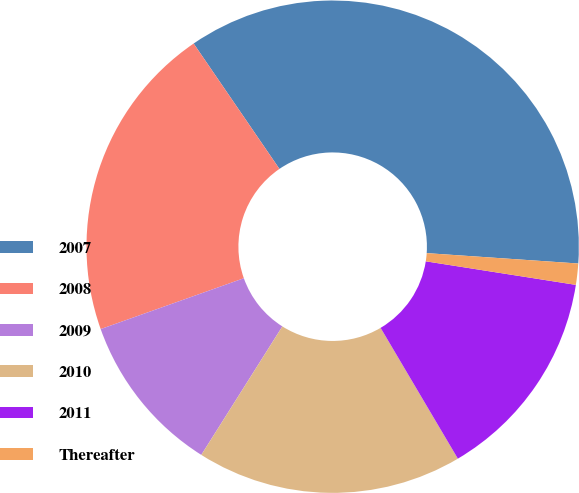Convert chart to OTSL. <chart><loc_0><loc_0><loc_500><loc_500><pie_chart><fcel>2007<fcel>2008<fcel>2009<fcel>2010<fcel>2011<fcel>Thereafter<nl><fcel>35.64%<fcel>20.88%<fcel>10.61%<fcel>17.45%<fcel>14.03%<fcel>1.39%<nl></chart> 